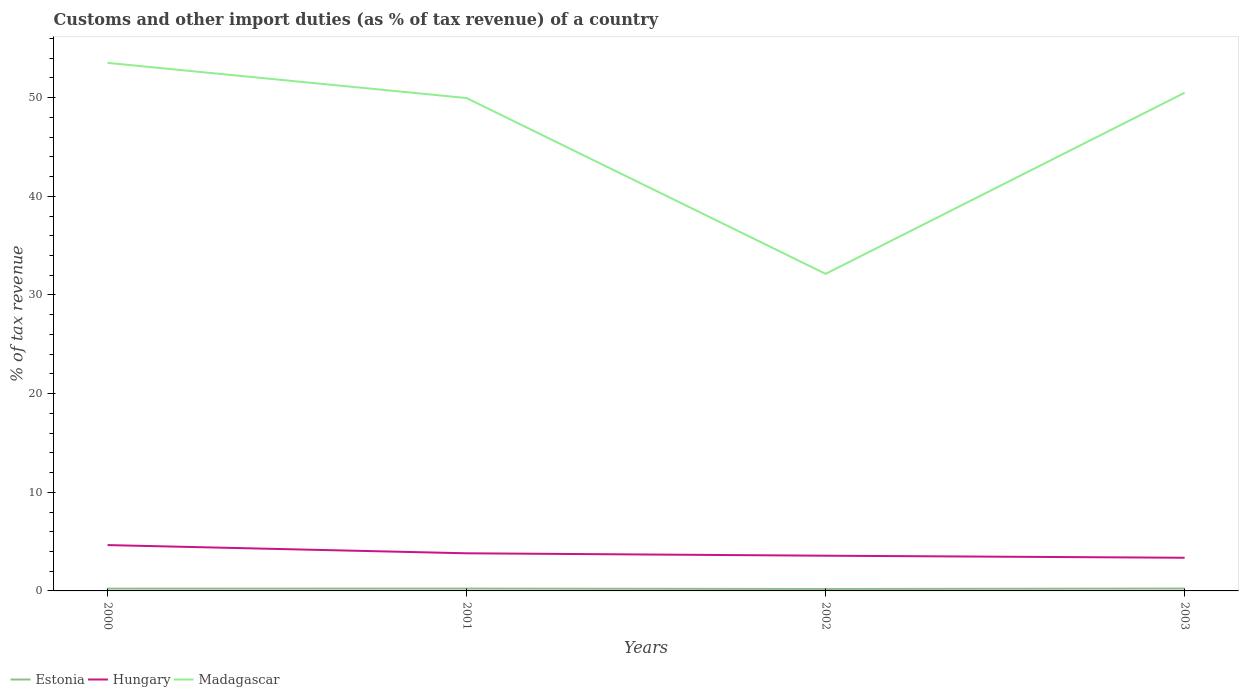Does the line corresponding to Estonia intersect with the line corresponding to Hungary?
Your response must be concise. No. Across all years, what is the maximum percentage of tax revenue from customs in Hungary?
Provide a short and direct response. 3.36. What is the total percentage of tax revenue from customs in Madagascar in the graph?
Your answer should be compact. 21.39. What is the difference between the highest and the second highest percentage of tax revenue from customs in Estonia?
Provide a succinct answer. 0.05. How many years are there in the graph?
Keep it short and to the point. 4. What is the difference between two consecutive major ticks on the Y-axis?
Your answer should be very brief. 10. Does the graph contain grids?
Keep it short and to the point. No. How many legend labels are there?
Your answer should be compact. 3. How are the legend labels stacked?
Offer a very short reply. Horizontal. What is the title of the graph?
Offer a terse response. Customs and other import duties (as % of tax revenue) of a country. Does "Algeria" appear as one of the legend labels in the graph?
Offer a terse response. No. What is the label or title of the Y-axis?
Make the answer very short. % of tax revenue. What is the % of tax revenue in Estonia in 2000?
Give a very brief answer. 0.23. What is the % of tax revenue in Hungary in 2000?
Your answer should be compact. 4.65. What is the % of tax revenue of Madagascar in 2000?
Your answer should be compact. 53.53. What is the % of tax revenue of Estonia in 2001?
Keep it short and to the point. 0.24. What is the % of tax revenue of Hungary in 2001?
Keep it short and to the point. 3.81. What is the % of tax revenue of Madagascar in 2001?
Your answer should be compact. 49.96. What is the % of tax revenue of Estonia in 2002?
Make the answer very short. 0.2. What is the % of tax revenue in Hungary in 2002?
Keep it short and to the point. 3.57. What is the % of tax revenue of Madagascar in 2002?
Your response must be concise. 32.14. What is the % of tax revenue in Estonia in 2003?
Provide a short and direct response. 0.24. What is the % of tax revenue of Hungary in 2003?
Keep it short and to the point. 3.36. What is the % of tax revenue of Madagascar in 2003?
Make the answer very short. 50.5. Across all years, what is the maximum % of tax revenue of Estonia?
Your answer should be compact. 0.24. Across all years, what is the maximum % of tax revenue of Hungary?
Provide a succinct answer. 4.65. Across all years, what is the maximum % of tax revenue in Madagascar?
Offer a very short reply. 53.53. Across all years, what is the minimum % of tax revenue of Estonia?
Offer a very short reply. 0.2. Across all years, what is the minimum % of tax revenue of Hungary?
Your answer should be compact. 3.36. Across all years, what is the minimum % of tax revenue of Madagascar?
Your response must be concise. 32.14. What is the total % of tax revenue in Estonia in the graph?
Offer a very short reply. 0.91. What is the total % of tax revenue of Hungary in the graph?
Give a very brief answer. 15.39. What is the total % of tax revenue of Madagascar in the graph?
Give a very brief answer. 186.13. What is the difference between the % of tax revenue in Estonia in 2000 and that in 2001?
Your answer should be very brief. -0. What is the difference between the % of tax revenue of Hungary in 2000 and that in 2001?
Your response must be concise. 0.83. What is the difference between the % of tax revenue of Madagascar in 2000 and that in 2001?
Make the answer very short. 3.56. What is the difference between the % of tax revenue of Estonia in 2000 and that in 2002?
Your answer should be very brief. 0.04. What is the difference between the % of tax revenue in Madagascar in 2000 and that in 2002?
Make the answer very short. 21.39. What is the difference between the % of tax revenue in Estonia in 2000 and that in 2003?
Offer a terse response. -0.01. What is the difference between the % of tax revenue of Hungary in 2000 and that in 2003?
Offer a very short reply. 1.28. What is the difference between the % of tax revenue in Madagascar in 2000 and that in 2003?
Make the answer very short. 3.03. What is the difference between the % of tax revenue in Estonia in 2001 and that in 2002?
Your response must be concise. 0.04. What is the difference between the % of tax revenue of Hungary in 2001 and that in 2002?
Ensure brevity in your answer.  0.24. What is the difference between the % of tax revenue in Madagascar in 2001 and that in 2002?
Ensure brevity in your answer.  17.82. What is the difference between the % of tax revenue of Estonia in 2001 and that in 2003?
Give a very brief answer. -0. What is the difference between the % of tax revenue of Hungary in 2001 and that in 2003?
Make the answer very short. 0.45. What is the difference between the % of tax revenue in Madagascar in 2001 and that in 2003?
Make the answer very short. -0.54. What is the difference between the % of tax revenue in Estonia in 2002 and that in 2003?
Your answer should be very brief. -0.04. What is the difference between the % of tax revenue of Hungary in 2002 and that in 2003?
Your answer should be compact. 0.21. What is the difference between the % of tax revenue of Madagascar in 2002 and that in 2003?
Ensure brevity in your answer.  -18.36. What is the difference between the % of tax revenue in Estonia in 2000 and the % of tax revenue in Hungary in 2001?
Ensure brevity in your answer.  -3.58. What is the difference between the % of tax revenue in Estonia in 2000 and the % of tax revenue in Madagascar in 2001?
Your answer should be very brief. -49.73. What is the difference between the % of tax revenue of Hungary in 2000 and the % of tax revenue of Madagascar in 2001?
Provide a short and direct response. -45.31. What is the difference between the % of tax revenue in Estonia in 2000 and the % of tax revenue in Hungary in 2002?
Provide a succinct answer. -3.34. What is the difference between the % of tax revenue in Estonia in 2000 and the % of tax revenue in Madagascar in 2002?
Offer a terse response. -31.91. What is the difference between the % of tax revenue of Hungary in 2000 and the % of tax revenue of Madagascar in 2002?
Offer a terse response. -27.49. What is the difference between the % of tax revenue in Estonia in 2000 and the % of tax revenue in Hungary in 2003?
Provide a short and direct response. -3.13. What is the difference between the % of tax revenue in Estonia in 2000 and the % of tax revenue in Madagascar in 2003?
Your answer should be compact. -50.27. What is the difference between the % of tax revenue in Hungary in 2000 and the % of tax revenue in Madagascar in 2003?
Provide a succinct answer. -45.85. What is the difference between the % of tax revenue in Estonia in 2001 and the % of tax revenue in Hungary in 2002?
Ensure brevity in your answer.  -3.33. What is the difference between the % of tax revenue in Estonia in 2001 and the % of tax revenue in Madagascar in 2002?
Offer a very short reply. -31.9. What is the difference between the % of tax revenue in Hungary in 2001 and the % of tax revenue in Madagascar in 2002?
Make the answer very short. -28.33. What is the difference between the % of tax revenue of Estonia in 2001 and the % of tax revenue of Hungary in 2003?
Provide a succinct answer. -3.13. What is the difference between the % of tax revenue of Estonia in 2001 and the % of tax revenue of Madagascar in 2003?
Your response must be concise. -50.26. What is the difference between the % of tax revenue of Hungary in 2001 and the % of tax revenue of Madagascar in 2003?
Offer a terse response. -46.69. What is the difference between the % of tax revenue in Estonia in 2002 and the % of tax revenue in Hungary in 2003?
Offer a terse response. -3.17. What is the difference between the % of tax revenue of Estonia in 2002 and the % of tax revenue of Madagascar in 2003?
Keep it short and to the point. -50.3. What is the difference between the % of tax revenue of Hungary in 2002 and the % of tax revenue of Madagascar in 2003?
Provide a short and direct response. -46.93. What is the average % of tax revenue of Estonia per year?
Provide a succinct answer. 0.23. What is the average % of tax revenue of Hungary per year?
Ensure brevity in your answer.  3.85. What is the average % of tax revenue of Madagascar per year?
Keep it short and to the point. 46.53. In the year 2000, what is the difference between the % of tax revenue in Estonia and % of tax revenue in Hungary?
Ensure brevity in your answer.  -4.41. In the year 2000, what is the difference between the % of tax revenue in Estonia and % of tax revenue in Madagascar?
Your answer should be very brief. -53.29. In the year 2000, what is the difference between the % of tax revenue of Hungary and % of tax revenue of Madagascar?
Your answer should be very brief. -48.88. In the year 2001, what is the difference between the % of tax revenue of Estonia and % of tax revenue of Hungary?
Provide a succinct answer. -3.58. In the year 2001, what is the difference between the % of tax revenue in Estonia and % of tax revenue in Madagascar?
Offer a terse response. -49.73. In the year 2001, what is the difference between the % of tax revenue of Hungary and % of tax revenue of Madagascar?
Your answer should be compact. -46.15. In the year 2002, what is the difference between the % of tax revenue in Estonia and % of tax revenue in Hungary?
Your response must be concise. -3.37. In the year 2002, what is the difference between the % of tax revenue of Estonia and % of tax revenue of Madagascar?
Offer a terse response. -31.94. In the year 2002, what is the difference between the % of tax revenue in Hungary and % of tax revenue in Madagascar?
Your response must be concise. -28.57. In the year 2003, what is the difference between the % of tax revenue in Estonia and % of tax revenue in Hungary?
Offer a terse response. -3.12. In the year 2003, what is the difference between the % of tax revenue in Estonia and % of tax revenue in Madagascar?
Your answer should be compact. -50.26. In the year 2003, what is the difference between the % of tax revenue in Hungary and % of tax revenue in Madagascar?
Your answer should be very brief. -47.14. What is the ratio of the % of tax revenue in Estonia in 2000 to that in 2001?
Your answer should be compact. 0.98. What is the ratio of the % of tax revenue of Hungary in 2000 to that in 2001?
Offer a terse response. 1.22. What is the ratio of the % of tax revenue in Madagascar in 2000 to that in 2001?
Your response must be concise. 1.07. What is the ratio of the % of tax revenue in Estonia in 2000 to that in 2002?
Your response must be concise. 1.18. What is the ratio of the % of tax revenue in Hungary in 2000 to that in 2002?
Offer a very short reply. 1.3. What is the ratio of the % of tax revenue in Madagascar in 2000 to that in 2002?
Offer a very short reply. 1.67. What is the ratio of the % of tax revenue in Estonia in 2000 to that in 2003?
Give a very brief answer. 0.96. What is the ratio of the % of tax revenue of Hungary in 2000 to that in 2003?
Offer a very short reply. 1.38. What is the ratio of the % of tax revenue in Madagascar in 2000 to that in 2003?
Your answer should be very brief. 1.06. What is the ratio of the % of tax revenue of Estonia in 2001 to that in 2002?
Your answer should be compact. 1.21. What is the ratio of the % of tax revenue of Hungary in 2001 to that in 2002?
Your response must be concise. 1.07. What is the ratio of the % of tax revenue of Madagascar in 2001 to that in 2002?
Your response must be concise. 1.55. What is the ratio of the % of tax revenue in Estonia in 2001 to that in 2003?
Make the answer very short. 0.98. What is the ratio of the % of tax revenue of Hungary in 2001 to that in 2003?
Give a very brief answer. 1.13. What is the ratio of the % of tax revenue in Madagascar in 2001 to that in 2003?
Your response must be concise. 0.99. What is the ratio of the % of tax revenue in Estonia in 2002 to that in 2003?
Provide a succinct answer. 0.81. What is the ratio of the % of tax revenue of Hungary in 2002 to that in 2003?
Offer a terse response. 1.06. What is the ratio of the % of tax revenue of Madagascar in 2002 to that in 2003?
Offer a very short reply. 0.64. What is the difference between the highest and the second highest % of tax revenue of Estonia?
Give a very brief answer. 0. What is the difference between the highest and the second highest % of tax revenue of Hungary?
Provide a succinct answer. 0.83. What is the difference between the highest and the second highest % of tax revenue of Madagascar?
Offer a terse response. 3.03. What is the difference between the highest and the lowest % of tax revenue of Estonia?
Provide a succinct answer. 0.04. What is the difference between the highest and the lowest % of tax revenue of Hungary?
Give a very brief answer. 1.28. What is the difference between the highest and the lowest % of tax revenue in Madagascar?
Offer a very short reply. 21.39. 